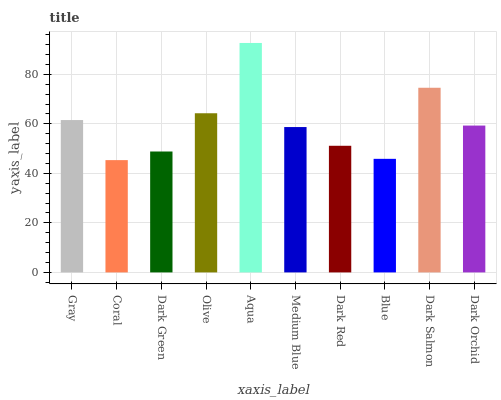Is Coral the minimum?
Answer yes or no. Yes. Is Aqua the maximum?
Answer yes or no. Yes. Is Dark Green the minimum?
Answer yes or no. No. Is Dark Green the maximum?
Answer yes or no. No. Is Dark Green greater than Coral?
Answer yes or no. Yes. Is Coral less than Dark Green?
Answer yes or no. Yes. Is Coral greater than Dark Green?
Answer yes or no. No. Is Dark Green less than Coral?
Answer yes or no. No. Is Dark Orchid the high median?
Answer yes or no. Yes. Is Medium Blue the low median?
Answer yes or no. Yes. Is Coral the high median?
Answer yes or no. No. Is Dark Green the low median?
Answer yes or no. No. 